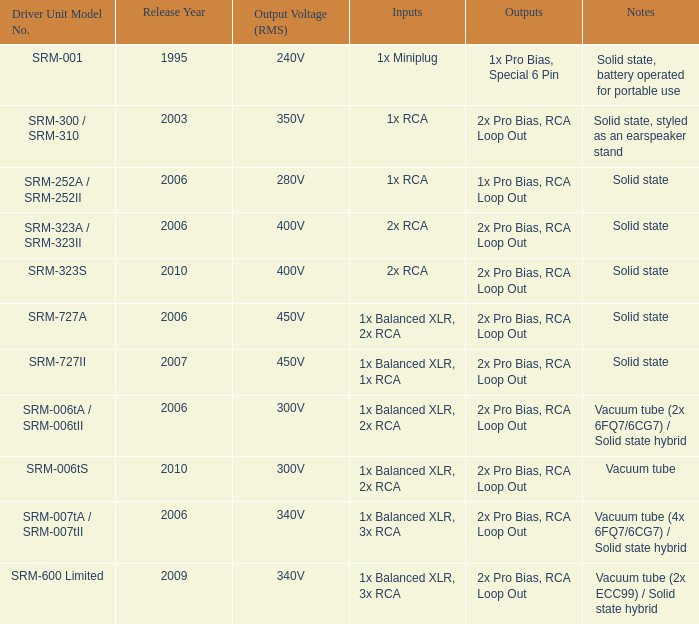Can you parse all the data within this table? {'header': ['Driver Unit Model No.', 'Release Year', 'Output Voltage (RMS)', 'Inputs', 'Outputs', 'Notes'], 'rows': [['SRM-001', '1995', '240V', '1x Miniplug', '1x Pro Bias, Special 6 Pin', 'Solid state, battery operated for portable use'], ['SRM-300 / SRM-310', '2003', '350V', '1x RCA', '2x Pro Bias, RCA Loop Out', 'Solid state, styled as an earspeaker stand'], ['SRM-252A / SRM-252II', '2006', '280V', '1x RCA', '1x Pro Bias, RCA Loop Out', 'Solid state'], ['SRM-323A / SRM-323II', '2006', '400V', '2x RCA', '2x Pro Bias, RCA Loop Out', 'Solid state'], ['SRM-323S', '2010', '400V', '2x RCA', '2x Pro Bias, RCA Loop Out', 'Solid state'], ['SRM-727A', '2006', '450V', '1x Balanced XLR, 2x RCA', '2x Pro Bias, RCA Loop Out', 'Solid state'], ['SRM-727II', '2007', '450V', '1x Balanced XLR, 1x RCA', '2x Pro Bias, RCA Loop Out', 'Solid state'], ['SRM-006tA / SRM-006tII', '2006', '300V', '1x Balanced XLR, 2x RCA', '2x Pro Bias, RCA Loop Out', 'Vacuum tube (2x 6FQ7/6CG7) / Solid state hybrid'], ['SRM-006tS', '2010', '300V', '1x Balanced XLR, 2x RCA', '2x Pro Bias, RCA Loop Out', 'Vacuum tube'], ['SRM-007tA / SRM-007tII', '2006', '340V', '1x Balanced XLR, 3x RCA', '2x Pro Bias, RCA Loop Out', 'Vacuum tube (4x 6FQ7/6CG7) / Solid state hybrid'], ['SRM-600 Limited', '2009', '340V', '1x Balanced XLR, 3x RCA', '2x Pro Bias, RCA Loop Out', 'Vacuum tube (2x ECC99) / Solid state hybrid']]} In which year were the features 2x pro bias, rca loop out, and vacuum tube notes introduced? 2010.0. 